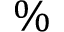<formula> <loc_0><loc_0><loc_500><loc_500>\%</formula> 